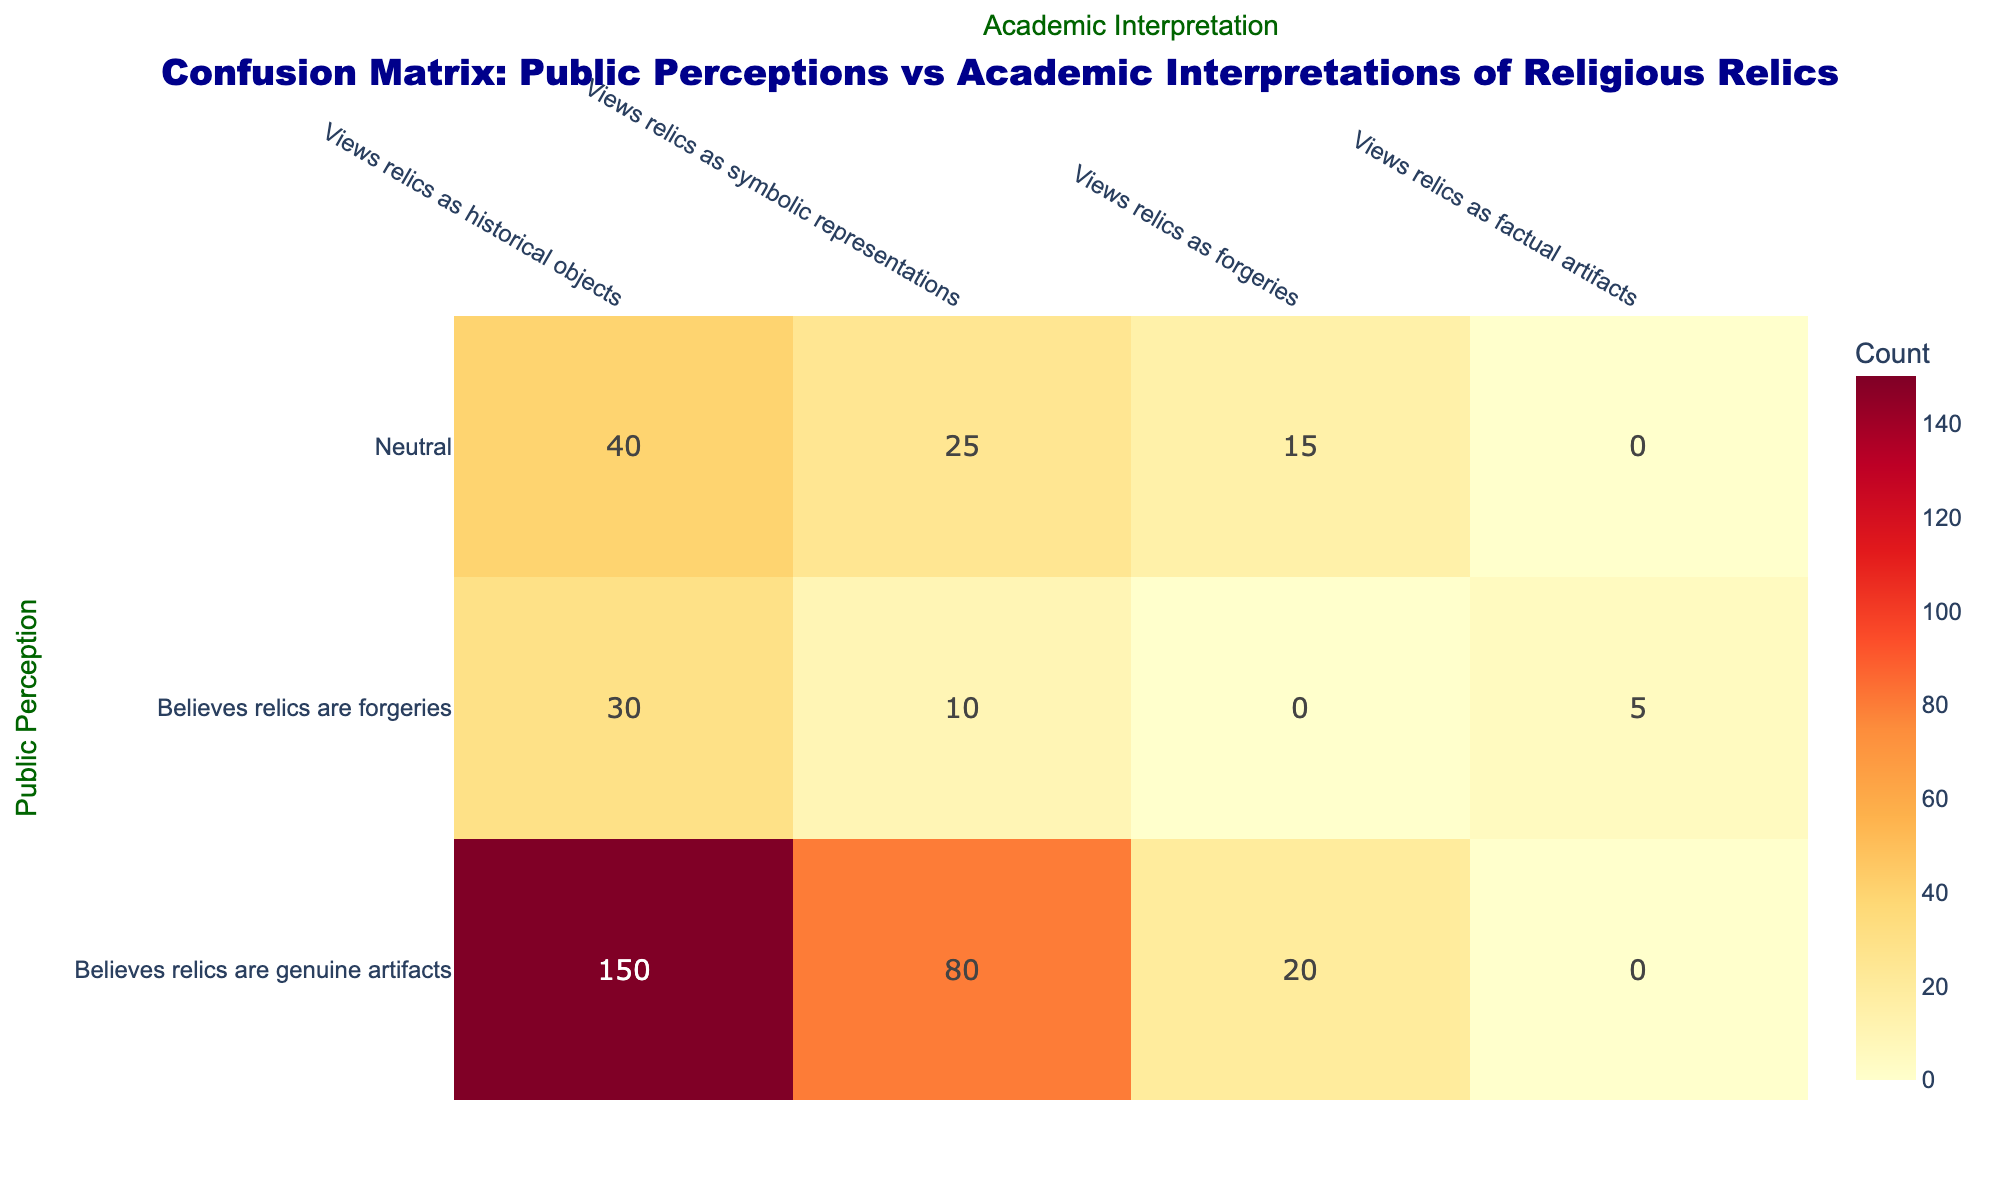What is the count of people who believe relics are genuine artifacts and view them as historical objects? According to the data, the cell corresponding to "Believes relics are genuine artifacts" and "Views relics as historical objects" shows the count of 150.
Answer: 150 What is the highest number of respondents in any category? Looking through the matrix, the highest count is in the cell for "Believes relics are genuine artifacts" and "Views relics as historical objects," which is 150, so this is the maximum value.
Answer: 150 How many people view relics as forgeries while believing they are forgeries? The corresponding cell for "Believes relics are forgeries" and "Views relics as forgeries" contains the count of 15.
Answer: 15 Is it true that the count of those who view relics as factual artifacts is greater than the count of individuals who believe relics are forgeries? The count for "Believes relics are forgeries" and "Views relics as factual artifacts" is 5, which is not greater than any of the counts for "Believes relics are forgeries.” Therefore, the statement is false.
Answer: No What is the total count of people who hold a neutral stance and see relics as symbolic representations? For the row "Neutral," the column "Views relics as symbolic representations" indicates a count of 25. Therefore, the total is simply taken from that specific cell.
Answer: 25 What is the combined count of those who believe relics are genuine artifacts and view them as either historical objects or symbolic representations? Summing the counts for "Believes relics are genuine artifacts" along the relevant columns gives 150 (historical objects) + 80 (symbolic representations) = 230. Thus, the total is 230.
Answer: 230 Is there more support for the idea that relics are genuine artifacts compared to the perception that they are forgeries? The total counts for "Believes relics are genuine artifacts" are 150 + 80 (symbolic representations) + 20 (forgeries) = 250. For "Believes relics are forgeries," the total is 30 + 10 (symbolic representations) + 5 (factual artifacts) = 45.  Since 250 exceeds 45, the idea that relics are genuine artifacts enjoys more support is true.
Answer: Yes How many respondents have a neutral perspective on relics as they relate to historical objects? From the neutral category, the count for "Views relics as historical objects" is listed as 40. Therefore, this is the specific value being asked.
Answer: 40 What is the difference in counts between those who believe relics are genuine artifacts and view them as forgeries versus those who believe relics are forgeries and view them as symbolic representations? The count for the first scenario ("Believes relics are genuine artifacts" and "Views relics as forgeries") is 20. The count for the second ("Believes relics are forgeries" and "Views relics as symbolic representations") is 10. The difference is calculated as 20 - 10 = 10.
Answer: 10 